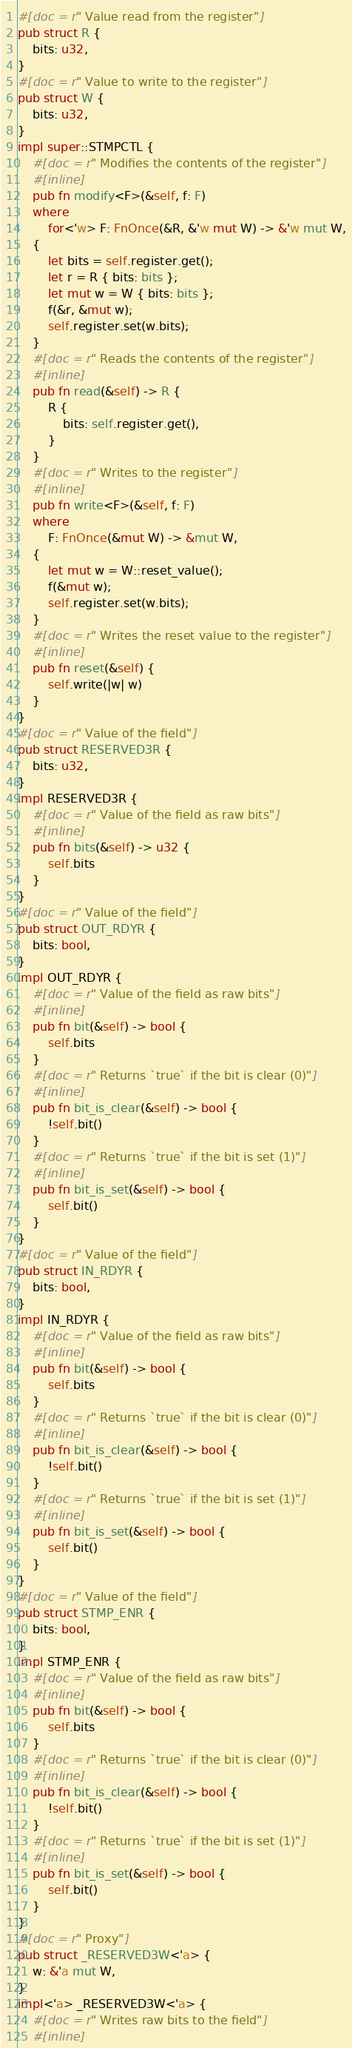<code> <loc_0><loc_0><loc_500><loc_500><_Rust_>#[doc = r" Value read from the register"]
pub struct R {
    bits: u32,
}
#[doc = r" Value to write to the register"]
pub struct W {
    bits: u32,
}
impl super::STMPCTL {
    #[doc = r" Modifies the contents of the register"]
    #[inline]
    pub fn modify<F>(&self, f: F)
    where
        for<'w> F: FnOnce(&R, &'w mut W) -> &'w mut W,
    {
        let bits = self.register.get();
        let r = R { bits: bits };
        let mut w = W { bits: bits };
        f(&r, &mut w);
        self.register.set(w.bits);
    }
    #[doc = r" Reads the contents of the register"]
    #[inline]
    pub fn read(&self) -> R {
        R {
            bits: self.register.get(),
        }
    }
    #[doc = r" Writes to the register"]
    #[inline]
    pub fn write<F>(&self, f: F)
    where
        F: FnOnce(&mut W) -> &mut W,
    {
        let mut w = W::reset_value();
        f(&mut w);
        self.register.set(w.bits);
    }
    #[doc = r" Writes the reset value to the register"]
    #[inline]
    pub fn reset(&self) {
        self.write(|w| w)
    }
}
#[doc = r" Value of the field"]
pub struct RESERVED3R {
    bits: u32,
}
impl RESERVED3R {
    #[doc = r" Value of the field as raw bits"]
    #[inline]
    pub fn bits(&self) -> u32 {
        self.bits
    }
}
#[doc = r" Value of the field"]
pub struct OUT_RDYR {
    bits: bool,
}
impl OUT_RDYR {
    #[doc = r" Value of the field as raw bits"]
    #[inline]
    pub fn bit(&self) -> bool {
        self.bits
    }
    #[doc = r" Returns `true` if the bit is clear (0)"]
    #[inline]
    pub fn bit_is_clear(&self) -> bool {
        !self.bit()
    }
    #[doc = r" Returns `true` if the bit is set (1)"]
    #[inline]
    pub fn bit_is_set(&self) -> bool {
        self.bit()
    }
}
#[doc = r" Value of the field"]
pub struct IN_RDYR {
    bits: bool,
}
impl IN_RDYR {
    #[doc = r" Value of the field as raw bits"]
    #[inline]
    pub fn bit(&self) -> bool {
        self.bits
    }
    #[doc = r" Returns `true` if the bit is clear (0)"]
    #[inline]
    pub fn bit_is_clear(&self) -> bool {
        !self.bit()
    }
    #[doc = r" Returns `true` if the bit is set (1)"]
    #[inline]
    pub fn bit_is_set(&self) -> bool {
        self.bit()
    }
}
#[doc = r" Value of the field"]
pub struct STMP_ENR {
    bits: bool,
}
impl STMP_ENR {
    #[doc = r" Value of the field as raw bits"]
    #[inline]
    pub fn bit(&self) -> bool {
        self.bits
    }
    #[doc = r" Returns `true` if the bit is clear (0)"]
    #[inline]
    pub fn bit_is_clear(&self) -> bool {
        !self.bit()
    }
    #[doc = r" Returns `true` if the bit is set (1)"]
    #[inline]
    pub fn bit_is_set(&self) -> bool {
        self.bit()
    }
}
#[doc = r" Proxy"]
pub struct _RESERVED3W<'a> {
    w: &'a mut W,
}
impl<'a> _RESERVED3W<'a> {
    #[doc = r" Writes raw bits to the field"]
    #[inline]</code> 